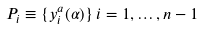<formula> <loc_0><loc_0><loc_500><loc_500>P _ { i } \equiv \{ y _ { i } ^ { a } ( \alpha ) \} \, i = 1 , \dots , n - 1</formula> 